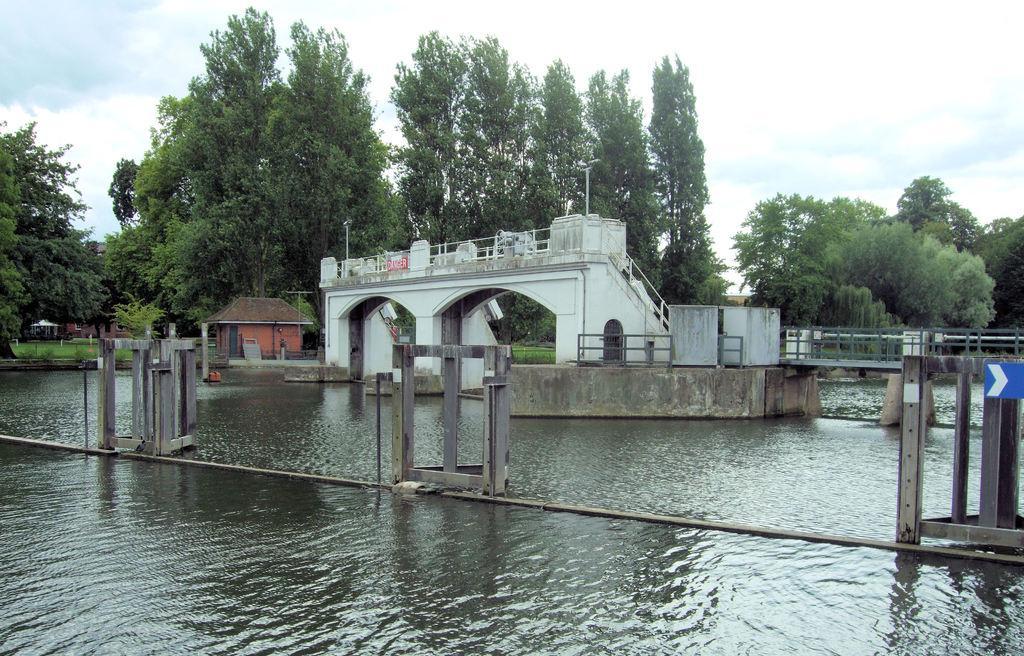Can you describe this image briefly? Here we can see water, bridge, poles, grass, trees, and houses. In the background there is sky with clouds. 